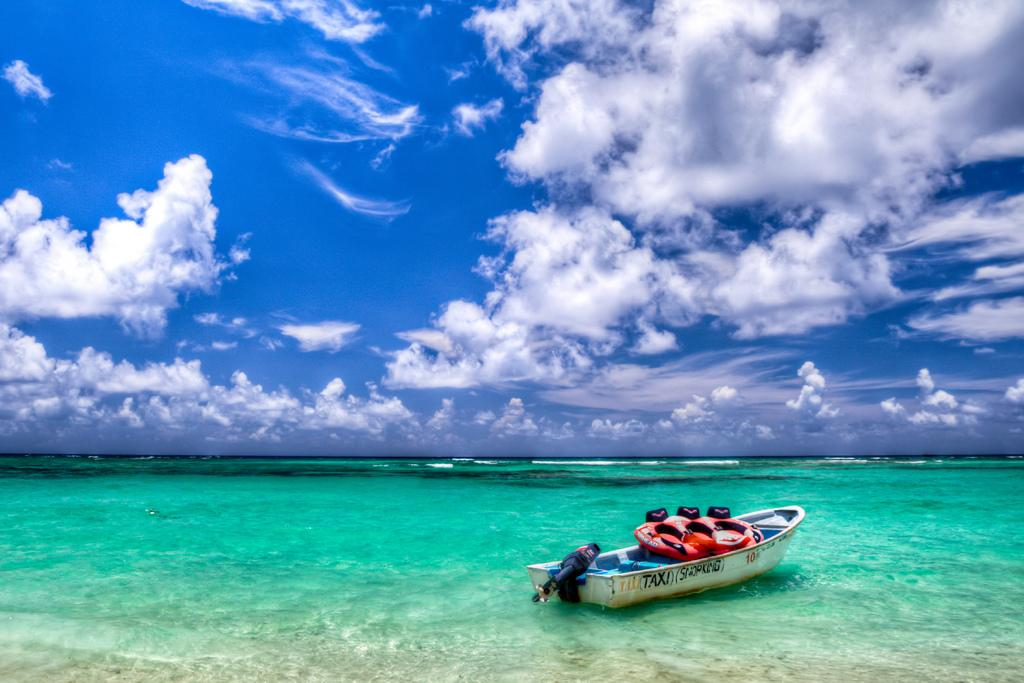<image>
Describe the image concisely. A small boat on a body of water with the word TAXI on the side. 